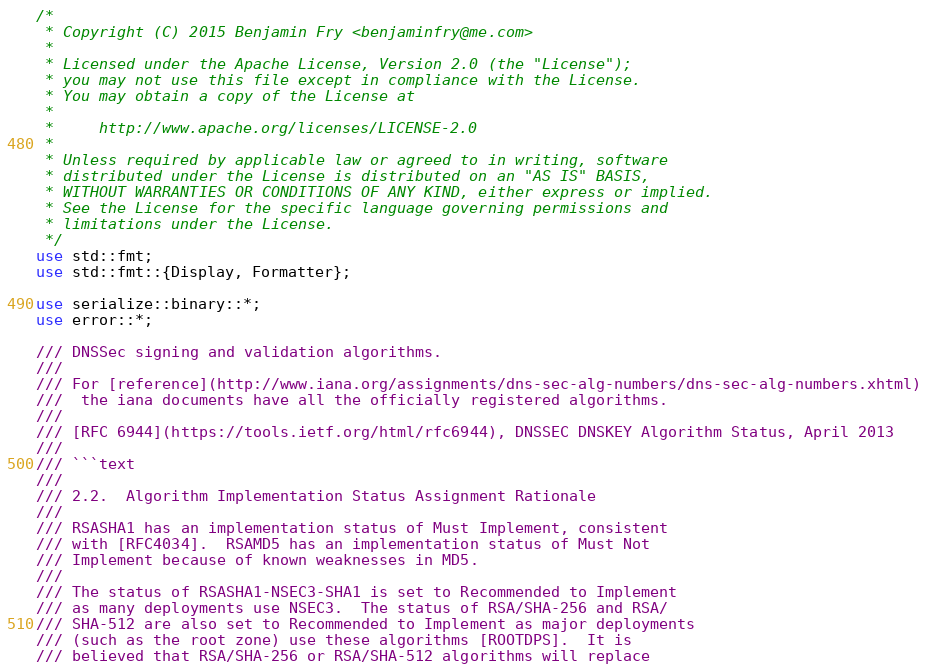Convert code to text. <code><loc_0><loc_0><loc_500><loc_500><_Rust_>/*
 * Copyright (C) 2015 Benjamin Fry <benjaminfry@me.com>
 *
 * Licensed under the Apache License, Version 2.0 (the "License");
 * you may not use this file except in compliance with the License.
 * You may obtain a copy of the License at
 *
 *     http://www.apache.org/licenses/LICENSE-2.0
 *
 * Unless required by applicable law or agreed to in writing, software
 * distributed under the License is distributed on an "AS IS" BASIS,
 * WITHOUT WARRANTIES OR CONDITIONS OF ANY KIND, either express or implied.
 * See the License for the specific language governing permissions and
 * limitations under the License.
 */
use std::fmt;
use std::fmt::{Display, Formatter};

use serialize::binary::*;
use error::*;

/// DNSSec signing and validation algorithms.
///
/// For [reference](http://www.iana.org/assignments/dns-sec-alg-numbers/dns-sec-alg-numbers.xhtml)
///  the iana documents have all the officially registered algorithms.
///
/// [RFC 6944](https://tools.ietf.org/html/rfc6944), DNSSEC DNSKEY Algorithm Status, April 2013
///
/// ```text
///
/// 2.2.  Algorithm Implementation Status Assignment Rationale
///
/// RSASHA1 has an implementation status of Must Implement, consistent
/// with [RFC4034].  RSAMD5 has an implementation status of Must Not
/// Implement because of known weaknesses in MD5.
///
/// The status of RSASHA1-NSEC3-SHA1 is set to Recommended to Implement
/// as many deployments use NSEC3.  The status of RSA/SHA-256 and RSA/
/// SHA-512 are also set to Recommended to Implement as major deployments
/// (such as the root zone) use these algorithms [ROOTDPS].  It is
/// believed that RSA/SHA-256 or RSA/SHA-512 algorithms will replace</code> 